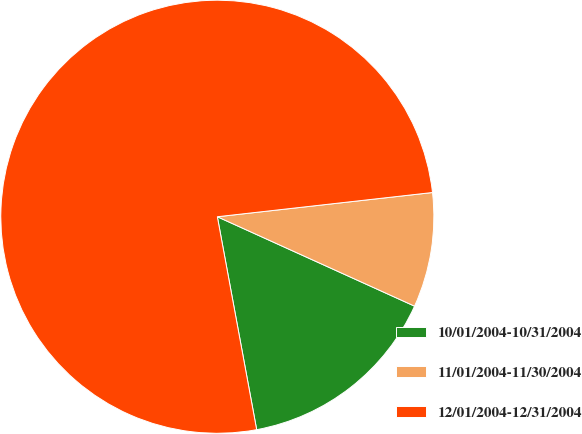<chart> <loc_0><loc_0><loc_500><loc_500><pie_chart><fcel>10/01/2004-10/31/2004<fcel>11/01/2004-11/30/2004<fcel>12/01/2004-12/31/2004<nl><fcel>15.32%<fcel>8.56%<fcel>76.13%<nl></chart> 